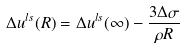Convert formula to latex. <formula><loc_0><loc_0><loc_500><loc_500>\Delta u ^ { l s } ( R ) = \Delta u ^ { l s } ( \infty ) - \frac { 3 \Delta \sigma } { \rho R }</formula> 